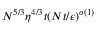<formula> <loc_0><loc_0><loc_500><loc_500>N ^ { 5 / 3 } \eta ^ { 4 / 3 } t ( N t / \epsilon ) ^ { o ( 1 ) }</formula> 